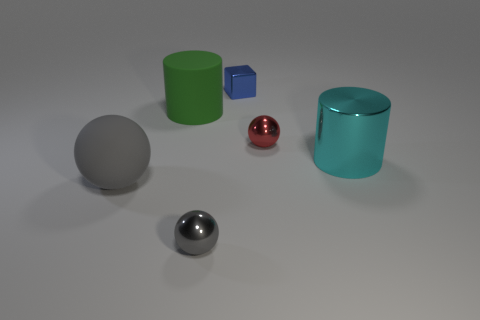There is a metal object that is the same color as the large rubber sphere; what is its shape?
Your response must be concise. Sphere. Are there more metal cylinders that are on the left side of the big gray rubber ball than small rubber spheres?
Offer a very short reply. No. Are there any big gray spheres made of the same material as the green thing?
Offer a terse response. Yes. Is the shape of the matte object that is behind the shiny cylinder the same as  the red metallic thing?
Your response must be concise. No. There is a tiny metal ball that is behind the tiny sphere left of the red shiny thing; what number of gray metallic spheres are right of it?
Your answer should be very brief. 0. Is the number of cyan things on the left side of the cyan metallic thing less than the number of cyan things that are in front of the red ball?
Make the answer very short. Yes. There is another shiny object that is the same shape as the red object; what is its color?
Offer a very short reply. Gray. The cyan metallic thing has what size?
Ensure brevity in your answer.  Large. What number of metal blocks are the same size as the cyan object?
Provide a succinct answer. 0. Do the big ball and the matte cylinder have the same color?
Your answer should be very brief. No. 